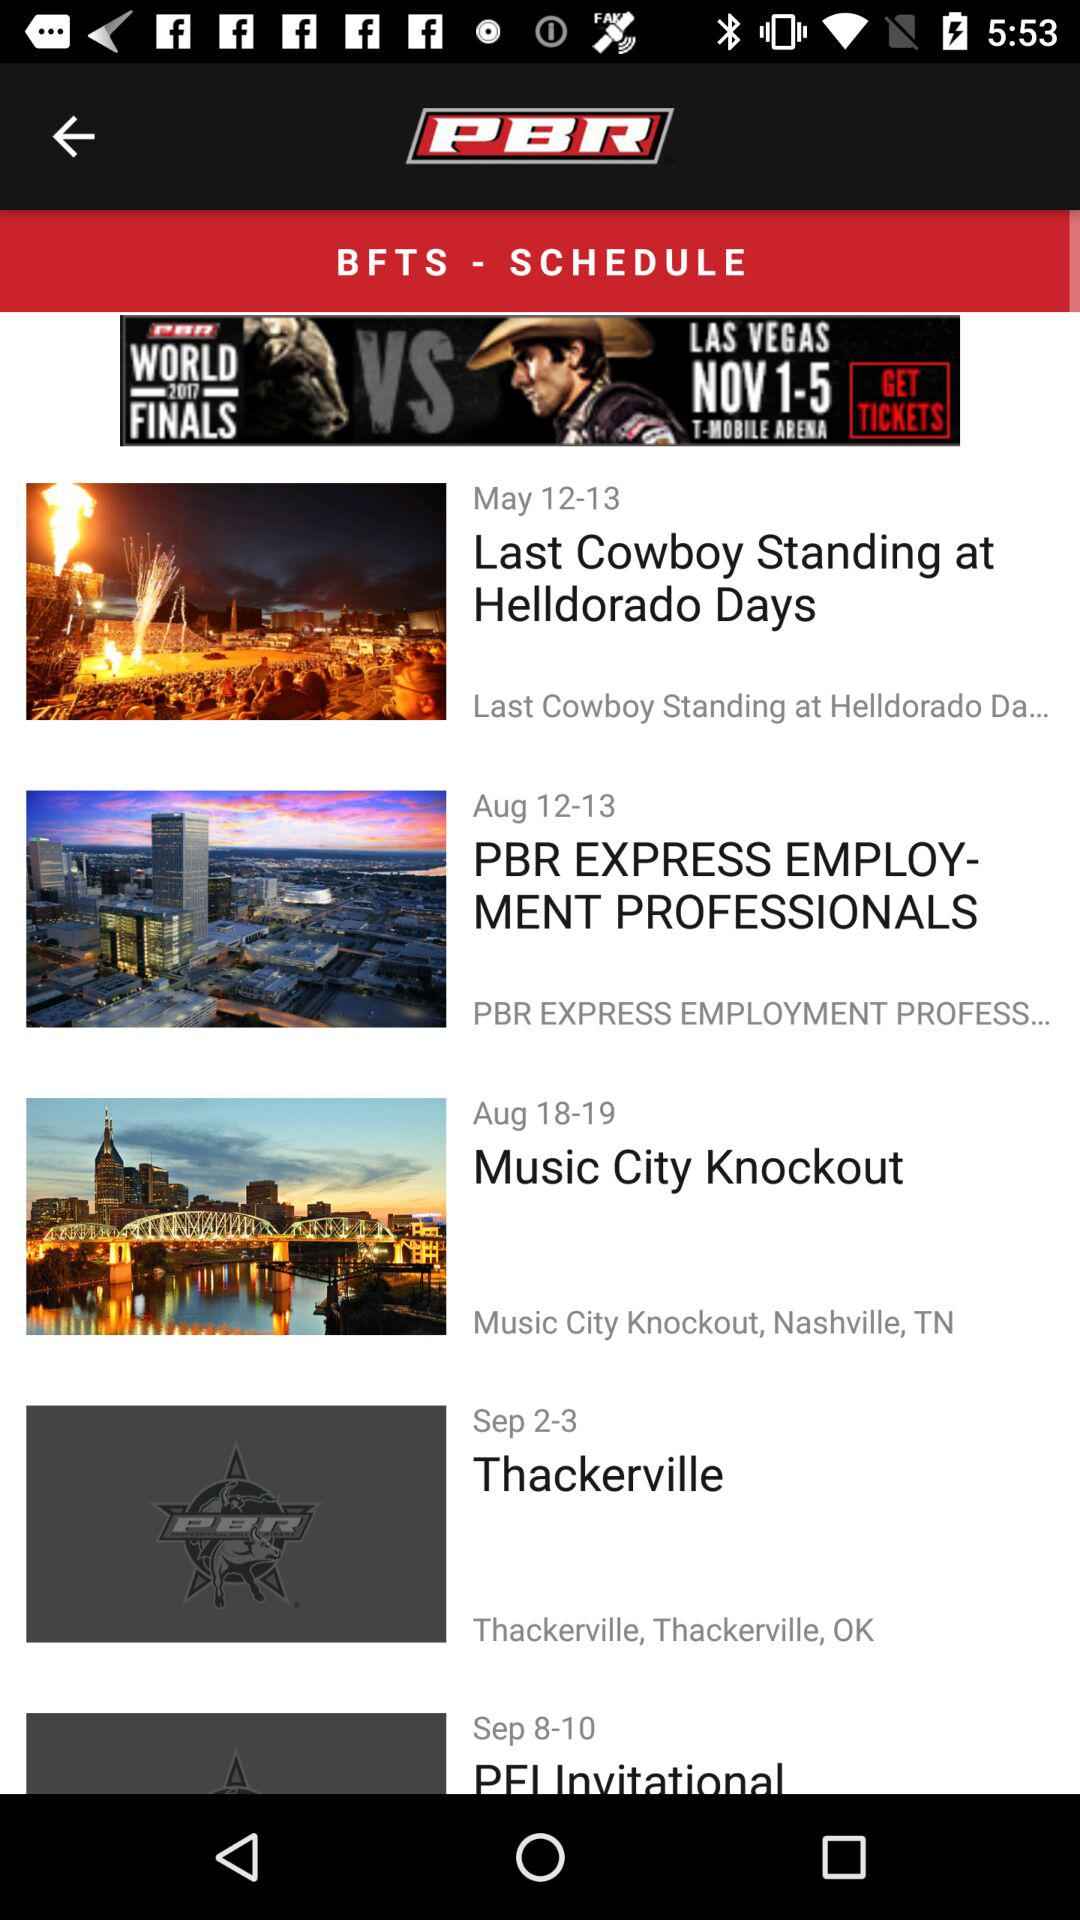When will Thackerville be released? Thackerville will be released between September 2 and September 3. 